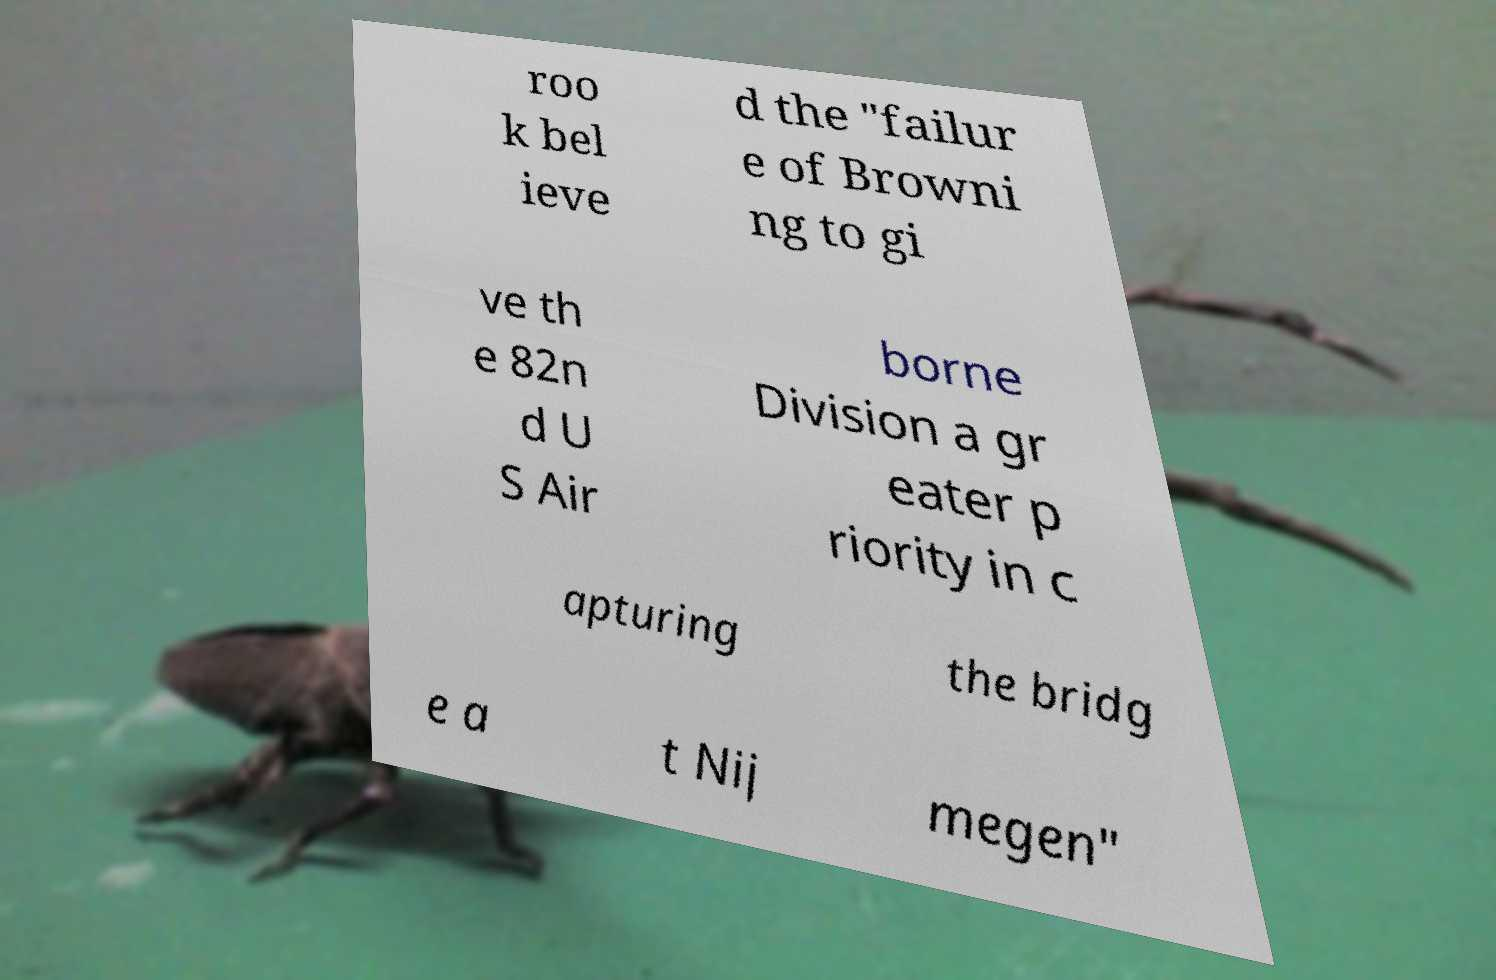I need the written content from this picture converted into text. Can you do that? roo k bel ieve d the "failur e of Browni ng to gi ve th e 82n d U S Air borne Division a gr eater p riority in c apturing the bridg e a t Nij megen" 